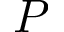Convert formula to latex. <formula><loc_0><loc_0><loc_500><loc_500>P</formula> 